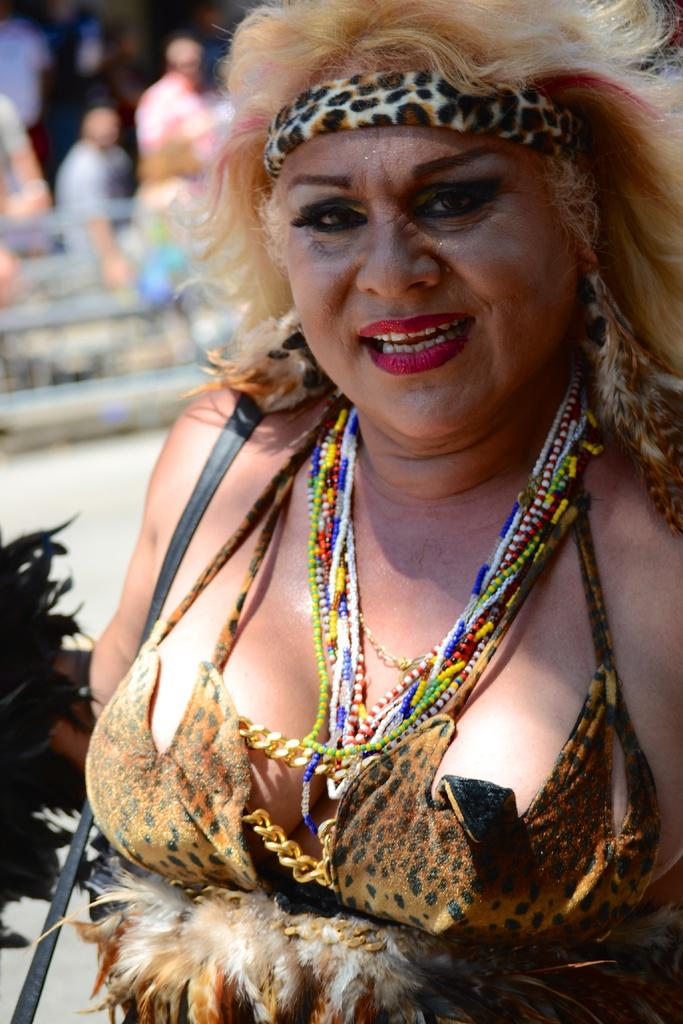Who is the main subject in the image? There is a woman in the image. What is the woman wearing on her head? The woman is wearing a headband. What type of accessory is the woman wearing? The woman is wearing chains. Can you describe the background of the image? The background of the image is blurred. How many eyes does the goat have in the image? There is no goat present in the image. What part of the woman's brain can be seen in the image? There is no part of the woman's brain visible in the image. 